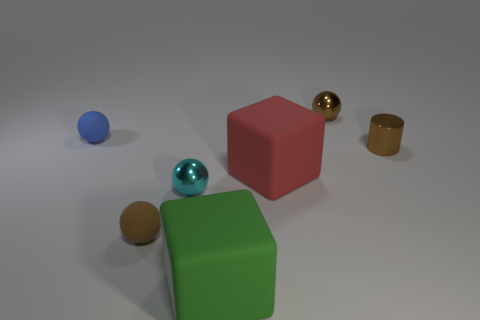What is the shape of the tiny metal thing that is in front of the red matte cube?
Ensure brevity in your answer.  Sphere. There is a small rubber object that is the same color as the tiny shiny cylinder; what shape is it?
Give a very brief answer. Sphere. What number of red balls have the same size as the brown cylinder?
Keep it short and to the point. 0. The cylinder has what color?
Ensure brevity in your answer.  Brown. Do the small cylinder and the metallic sphere to the right of the cyan thing have the same color?
Your response must be concise. Yes. There is a brown ball that is made of the same material as the red cube; what is its size?
Your answer should be compact. Small. Are there any matte objects that have the same color as the small metallic cylinder?
Give a very brief answer. Yes. What number of things are objects that are behind the tiny cyan thing or cyan metallic balls?
Keep it short and to the point. 5. Do the green cube and the large block right of the large green object have the same material?
Your response must be concise. Yes. Is there a small object made of the same material as the cyan ball?
Offer a terse response. Yes. 